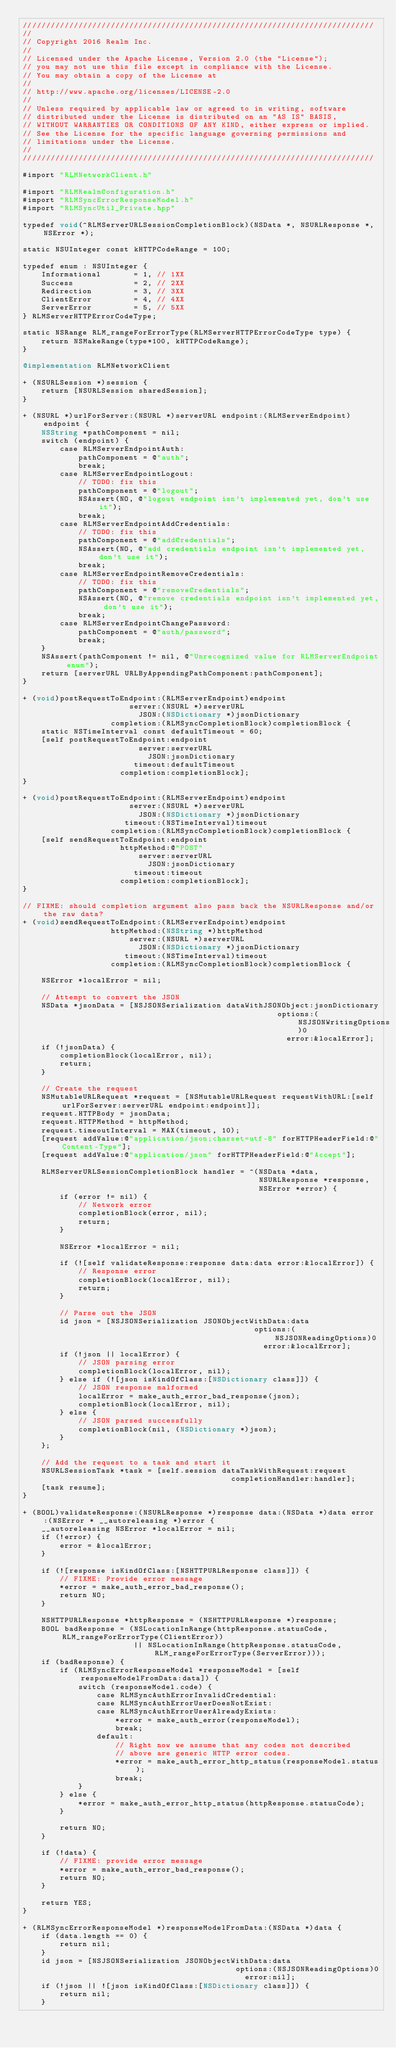Convert code to text. <code><loc_0><loc_0><loc_500><loc_500><_ObjectiveC_>////////////////////////////////////////////////////////////////////////////
//
// Copyright 2016 Realm Inc.
//
// Licensed under the Apache License, Version 2.0 (the "License");
// you may not use this file except in compliance with the License.
// You may obtain a copy of the License at
//
// http://www.apache.org/licenses/LICENSE-2.0
//
// Unless required by applicable law or agreed to in writing, software
// distributed under the License is distributed on an "AS IS" BASIS,
// WITHOUT WARRANTIES OR CONDITIONS OF ANY KIND, either express or implied.
// See the License for the specific language governing permissions and
// limitations under the License.
//
////////////////////////////////////////////////////////////////////////////

#import "RLMNetworkClient.h"

#import "RLMRealmConfiguration.h"
#import "RLMSyncErrorResponseModel.h"
#import "RLMSyncUtil_Private.hpp"

typedef void(^RLMServerURLSessionCompletionBlock)(NSData *, NSURLResponse *, NSError *);

static NSUInteger const kHTTPCodeRange = 100;

typedef enum : NSUInteger {
    Informational       = 1, // 1XX
    Success             = 2, // 2XX
    Redirection         = 3, // 3XX
    ClientError         = 4, // 4XX
    ServerError         = 5, // 5XX
} RLMServerHTTPErrorCodeType;

static NSRange RLM_rangeForErrorType(RLMServerHTTPErrorCodeType type) {
    return NSMakeRange(type*100, kHTTPCodeRange);
}

@implementation RLMNetworkClient

+ (NSURLSession *)session {
    return [NSURLSession sharedSession];
}

+ (NSURL *)urlForServer:(NSURL *)serverURL endpoint:(RLMServerEndpoint)endpoint {
    NSString *pathComponent = nil;
    switch (endpoint) {
        case RLMServerEndpointAuth:
            pathComponent = @"auth";
            break;
        case RLMServerEndpointLogout:
            // TODO: fix this
            pathComponent = @"logout";
            NSAssert(NO, @"logout endpoint isn't implemented yet, don't use it");
            break;
        case RLMServerEndpointAddCredentials:
            // TODO: fix this
            pathComponent = @"addCredentials";
            NSAssert(NO, @"add credentials endpoint isn't implemented yet, don't use it");
            break;
        case RLMServerEndpointRemoveCredentials:
            // TODO: fix this
            pathComponent = @"removeCredentials";
            NSAssert(NO, @"remove credentials endpoint isn't implemented yet, don't use it");
            break;
        case RLMServerEndpointChangePassword:
            pathComponent = @"auth/password";
            break;
    }
    NSAssert(pathComponent != nil, @"Unrecognized value for RLMServerEndpoint enum");
    return [serverURL URLByAppendingPathComponent:pathComponent];
}

+ (void)postRequestToEndpoint:(RLMServerEndpoint)endpoint
                       server:(NSURL *)serverURL
                         JSON:(NSDictionary *)jsonDictionary
                   completion:(RLMSyncCompletionBlock)completionBlock {
    static NSTimeInterval const defaultTimeout = 60;
    [self postRequestToEndpoint:endpoint
                         server:serverURL
                           JSON:jsonDictionary
                        timeout:defaultTimeout
                     completion:completionBlock];
}

+ (void)postRequestToEndpoint:(RLMServerEndpoint)endpoint
                       server:(NSURL *)serverURL
                         JSON:(NSDictionary *)jsonDictionary
                      timeout:(NSTimeInterval)timeout
                   completion:(RLMSyncCompletionBlock)completionBlock {
    [self sendRequestToEndpoint:endpoint
                     httpMethod:@"POST"
                         server:serverURL
                           JSON:jsonDictionary
                        timeout:timeout
                     completion:completionBlock];
}

// FIXME: should completion argument also pass back the NSURLResponse and/or the raw data?
+ (void)sendRequestToEndpoint:(RLMServerEndpoint)endpoint
                   httpMethod:(NSString *)httpMethod
                       server:(NSURL *)serverURL
                         JSON:(NSDictionary *)jsonDictionary
                      timeout:(NSTimeInterval)timeout
                   completion:(RLMSyncCompletionBlock)completionBlock {

    NSError *localError = nil;

    // Attempt to convert the JSON
    NSData *jsonData = [NSJSONSerialization dataWithJSONObject:jsonDictionary
                                                       options:(NSJSONWritingOptions)0
                                                         error:&localError];
    if (!jsonData) {
        completionBlock(localError, nil);
        return;
    }

    // Create the request
    NSMutableURLRequest *request = [NSMutableURLRequest requestWithURL:[self urlForServer:serverURL endpoint:endpoint]];
    request.HTTPBody = jsonData;
    request.HTTPMethod = httpMethod;
    request.timeoutInterval = MAX(timeout, 10);
    [request addValue:@"application/json;charset=utf-8" forHTTPHeaderField:@"Content-Type"];
    [request addValue:@"application/json" forHTTPHeaderField:@"Accept"];

    RLMServerURLSessionCompletionBlock handler = ^(NSData *data,
                                                   NSURLResponse *response,
                                                   NSError *error) {
        if (error != nil) {
            // Network error
            completionBlock(error, nil);
            return;
        }

        NSError *localError = nil;

        if (![self validateResponse:response data:data error:&localError]) {
            // Response error
            completionBlock(localError, nil);
            return;
        }

        // Parse out the JSON
        id json = [NSJSONSerialization JSONObjectWithData:data
                                                  options:(NSJSONReadingOptions)0
                                                    error:&localError];
        if (!json || localError) {
            // JSON parsing error
            completionBlock(localError, nil);
        } else if (![json isKindOfClass:[NSDictionary class]]) {
            // JSON response malformed
            localError = make_auth_error_bad_response(json);
            completionBlock(localError, nil);
        } else {
            // JSON parsed successfully
            completionBlock(nil, (NSDictionary *)json);
        }
    };

    // Add the request to a task and start it
    NSURLSessionTask *task = [self.session dataTaskWithRequest:request
                                             completionHandler:handler];
    [task resume];
}

+ (BOOL)validateResponse:(NSURLResponse *)response data:(NSData *)data error:(NSError * __autoreleasing *)error {
    __autoreleasing NSError *localError = nil;
    if (!error) {
        error = &localError;
    }

    if (![response isKindOfClass:[NSHTTPURLResponse class]]) {
        // FIXME: Provide error message
        *error = make_auth_error_bad_response();
        return NO;
    }

    NSHTTPURLResponse *httpResponse = (NSHTTPURLResponse *)response;
    BOOL badResponse = (NSLocationInRange(httpResponse.statusCode, RLM_rangeForErrorType(ClientError))
                        || NSLocationInRange(httpResponse.statusCode, RLM_rangeForErrorType(ServerError)));
    if (badResponse) {
        if (RLMSyncErrorResponseModel *responseModel = [self responseModelFromData:data]) {
            switch (responseModel.code) {
                case RLMSyncAuthErrorInvalidCredential:
                case RLMSyncAuthErrorUserDoesNotExist:
                case RLMSyncAuthErrorUserAlreadyExists:
                    *error = make_auth_error(responseModel);
                    break;
                default:
                    // Right now we assume that any codes not described
                    // above are generic HTTP error codes.
                    *error = make_auth_error_http_status(responseModel.status);
                    break;
            }
        } else {
            *error = make_auth_error_http_status(httpResponse.statusCode);
        }

        return NO;
    }

    if (!data) {
        // FIXME: provide error message
        *error = make_auth_error_bad_response();
        return NO;
    }

    return YES;
}

+ (RLMSyncErrorResponseModel *)responseModelFromData:(NSData *)data {
    if (data.length == 0) {
        return nil;
    }
    id json = [NSJSONSerialization JSONObjectWithData:data
                                              options:(NSJSONReadingOptions)0
                                                error:nil];
    if (!json || ![json isKindOfClass:[NSDictionary class]]) {
        return nil;
    }</code> 